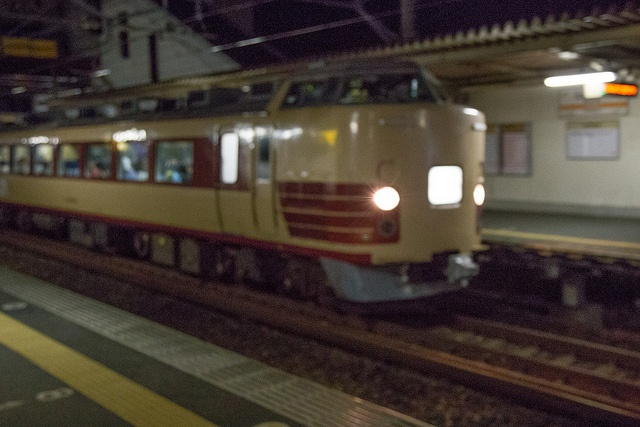Describe the objects in this image and their specific colors. I can see train in black, gray, and maroon tones, people in black, gray, and purple tones, people in black, gray, and darkgray tones, people in black and gray tones, and people in black, blue, and darkblue tones in this image. 